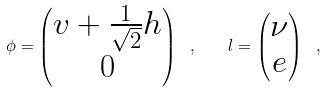<formula> <loc_0><loc_0><loc_500><loc_500>\phi = \begin{pmatrix} v + \frac { 1 } { \sqrt { 2 } } h \\ 0 \end{pmatrix} \ , \quad l = \begin{pmatrix} \nu \\ e \end{pmatrix} \ ,</formula> 